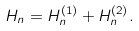Convert formula to latex. <formula><loc_0><loc_0><loc_500><loc_500>H _ { n } = H _ { n } ^ { ( 1 ) } + H _ { n } ^ { ( 2 ) } .</formula> 